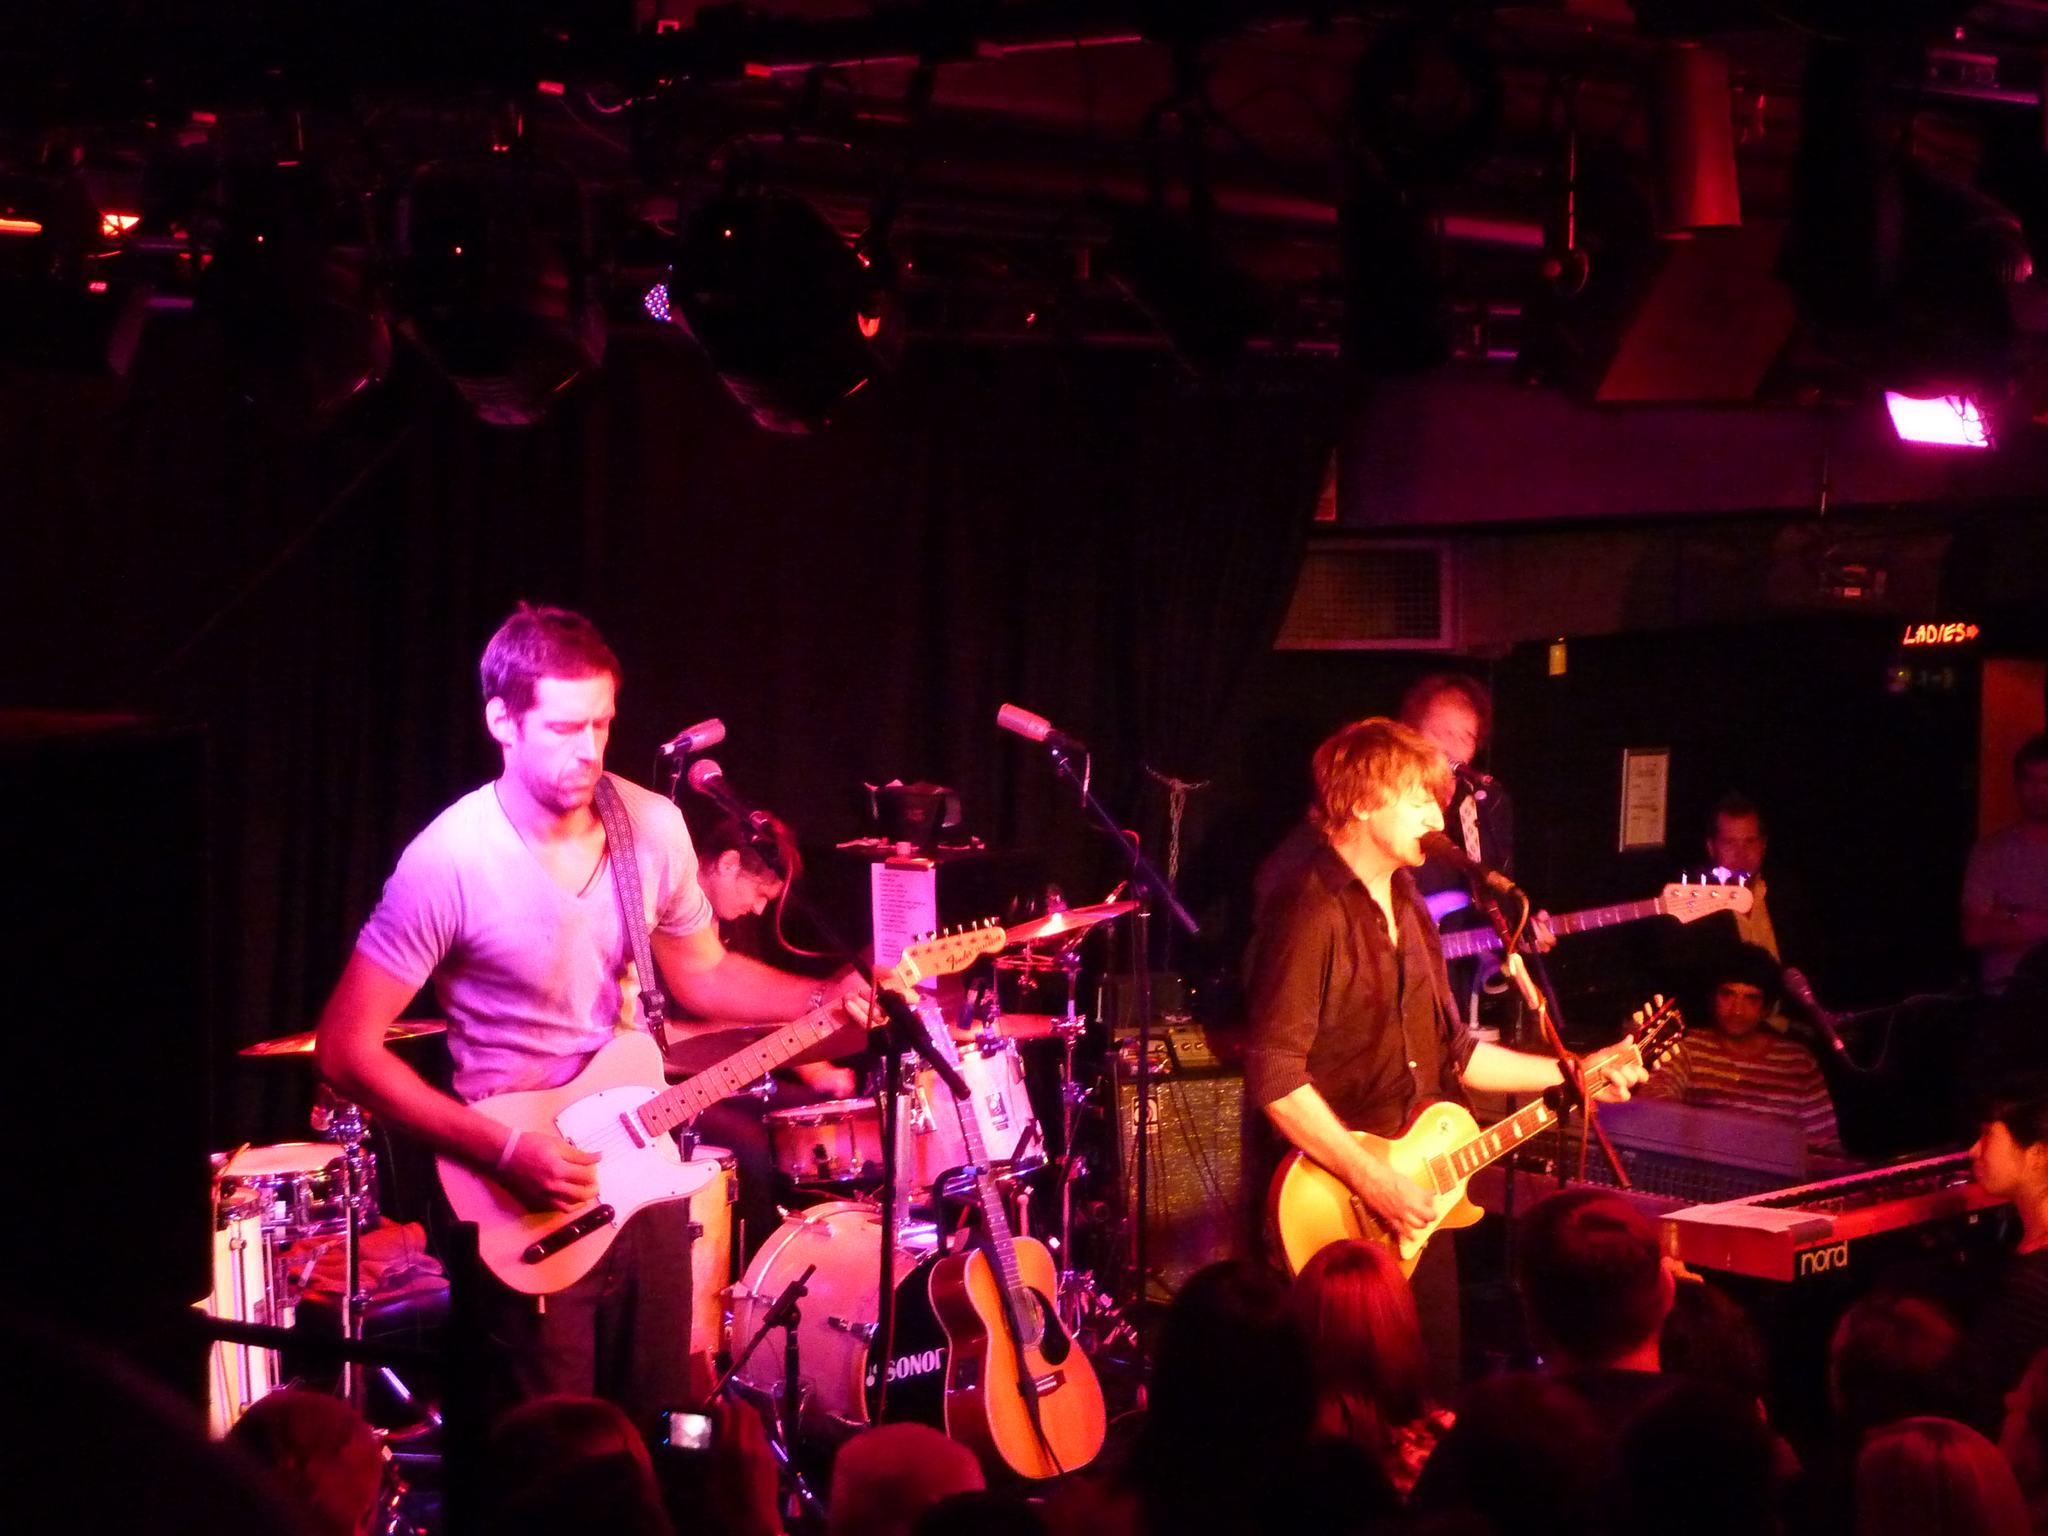Could you give a brief overview of what you see in this image? It looks like a music show there are musicians playing music with guitars and other musical instruments there is a lot of lighting on them in the background there is a dark cloth. 